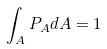Convert formula to latex. <formula><loc_0><loc_0><loc_500><loc_500>\int _ { A } P _ { A } d A = 1</formula> 